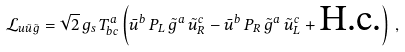Convert formula to latex. <formula><loc_0><loc_0><loc_500><loc_500>\mathcal { L } _ { u \tilde { u } \tilde { g } } = \sqrt { 2 } \, g _ { s } \, T ^ { a } _ { b c } \left ( \bar { u } ^ { b } \, P _ { L } \, \tilde { g } ^ { a } \, \tilde { u } ^ { c } _ { R } - \bar { u } ^ { b } \, P _ { R } \, \tilde { g } ^ { a } \, \tilde { u } ^ { c } _ { L } + \text {H.c.} \right ) \, ,</formula> 